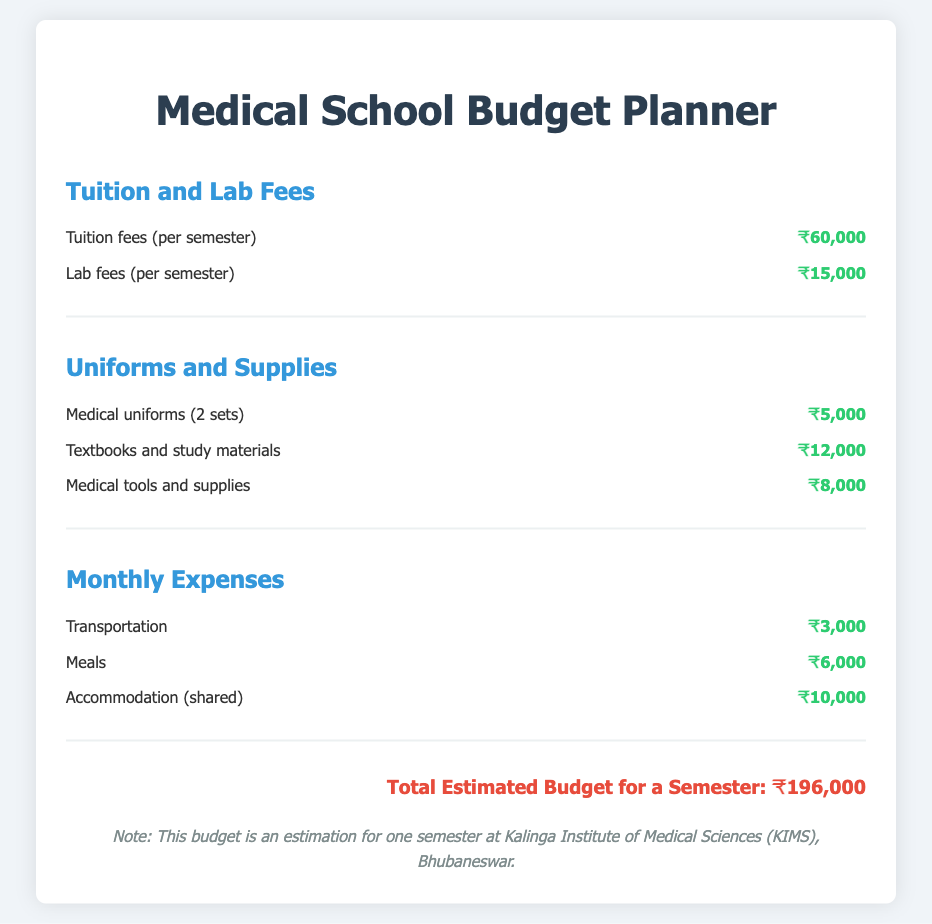What is the tuition fee per semester? The tuition fee is a specific amount listed under the Tuition and Lab Fees section of the budget, which is ₹60,000.
Answer: ₹60,000 What are the lab fees? The lab fees are specifically mentioned in the document under the Tuition and Lab Fees section, which amount to ₹15,000.
Answer: ₹15,000 How much do medical uniforms cost? The cost of medical uniforms is located in the Uniforms and Supplies section of the budget, which is ₹5,000 for two sets.
Answer: ₹5,000 What is the total estimated budget for a semester? The total estimated budget is the aggregate of all individual costs highlighted throughout the document, culminating in ₹196,000.
Answer: ₹196,000 How much will transportation cost monthly? The transportation cost is specified in the Monthly Expenses section of the budget, which is ₹3,000.
Answer: ₹3,000 What is the cost of textbooks and study materials? This cost is listed in the Uniforms and Supplies section and amounts to ₹12,000.
Answer: ₹12,000 What is the accommodation cost if shared? The document specifies that shared accommodation costs ₹10,000, which is under the Monthly Expenses section.
Answer: ₹10,000 What is the total for meals per month? The cost of meals per month is mentioned in the Monthly Expenses section, which is ₹6,000.
Answer: ₹6,000 Total Uniform and Supplies costs? The total for Uniform and Supplies includes medical uniforms, textbooks, and medical tools, amounting to ₹25,000 (₹5,000 + ₹12,000 + ₹8,000).
Answer: ₹25,000 